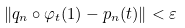<formula> <loc_0><loc_0><loc_500><loc_500>\| q _ { n } \circ \varphi _ { t } ( 1 ) - p _ { n } ( t ) \| < \varepsilon</formula> 